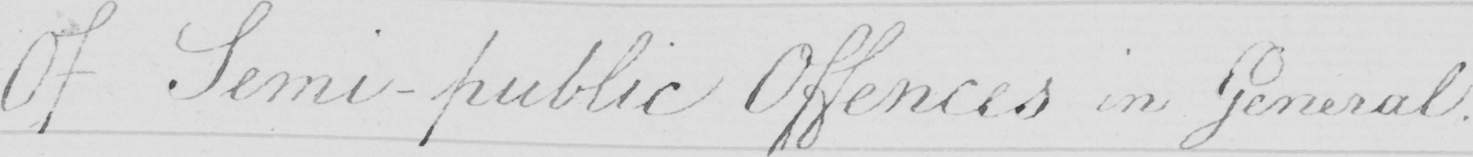Can you read and transcribe this handwriting? Of Semi-public Offences in General . 